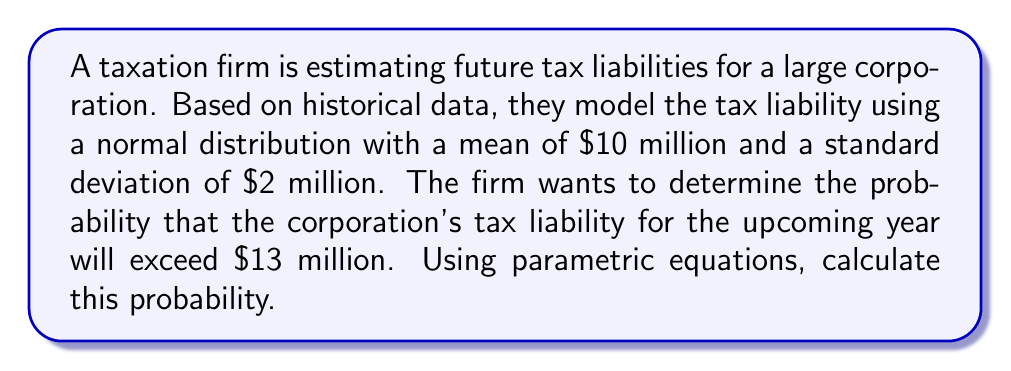Can you answer this question? To solve this problem, we'll use the properties of the normal distribution and the concept of z-scores.

1) Let X be the random variable representing the tax liability. We know that X follows a normal distribution with:
   $\mu = 10$ million (mean)
   $\sigma = 2$ million (standard deviation)

2) We want to find P(X > 13), the probability that X exceeds $13 million.

3) To use the standard normal distribution table, we need to convert this to a z-score. The formula for z-score is:

   $$z = \frac{x - \mu}{\sigma}$$

4) Substituting our values:

   $$z = \frac{13 - 10}{2} = \frac{3}{2} = 1.5$$

5) Now we need to find P(Z > 1.5) where Z is the standard normal variable.

6) Using a standard normal table or calculator, we can find that:
   P(Z < 1.5) ≈ 0.9332

7) Since we want the probability of exceeding this value:
   P(Z > 1.5) = 1 - P(Z < 1.5) = 1 - 0.9332 = 0.0668

8) Therefore, the probability that the tax liability will exceed $13 million is approximately 0.0668 or 6.68%.
Answer: The probability that the corporation's tax liability for the upcoming year will exceed $13 million is approximately 0.0668 or 6.68%. 